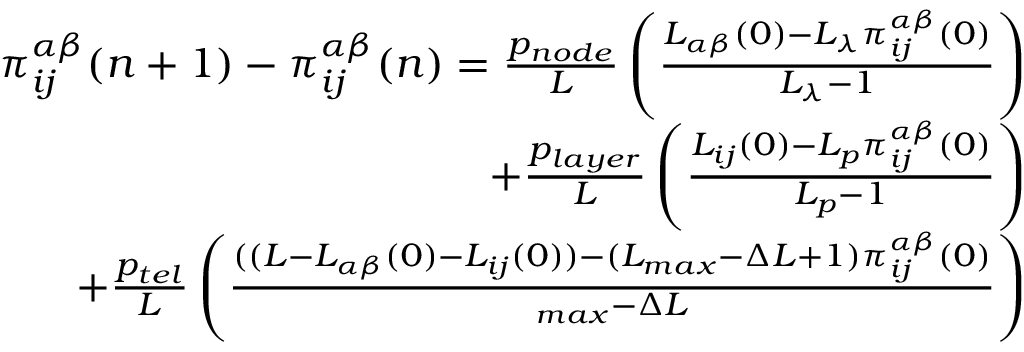Convert formula to latex. <formula><loc_0><loc_0><loc_500><loc_500>\begin{array} { r } { \pi _ { i j } ^ { \alpha \beta } ( n + 1 ) - \pi _ { i j } ^ { \alpha \beta } ( n ) = \frac { p _ { n o d e } } { L } \left ( \frac { L _ { \alpha \beta } ( 0 ) - L _ { \lambda } \pi _ { i j } ^ { \alpha \beta } ( 0 ) } { L _ { \lambda } - 1 } \right ) } \\ { + \frac { p _ { l a y e r } } { L } \left ( \frac { L _ { i j } ( 0 ) - L _ { p } \pi _ { i j } ^ { \alpha \beta } ( 0 ) } { L _ { p } - 1 } \right ) } \\ { + \frac { p _ { t e l } } { L } \left ( \frac { ( ( L - L _ { \alpha \beta } ( 0 ) - L _ { i j } ( 0 ) ) - ( L _ { \max } - \Delta L + 1 ) \pi _ { i j } ^ { \alpha \beta } ( 0 ) } { \L _ { \max } - \Delta L } \right ) } \end{array}</formula> 